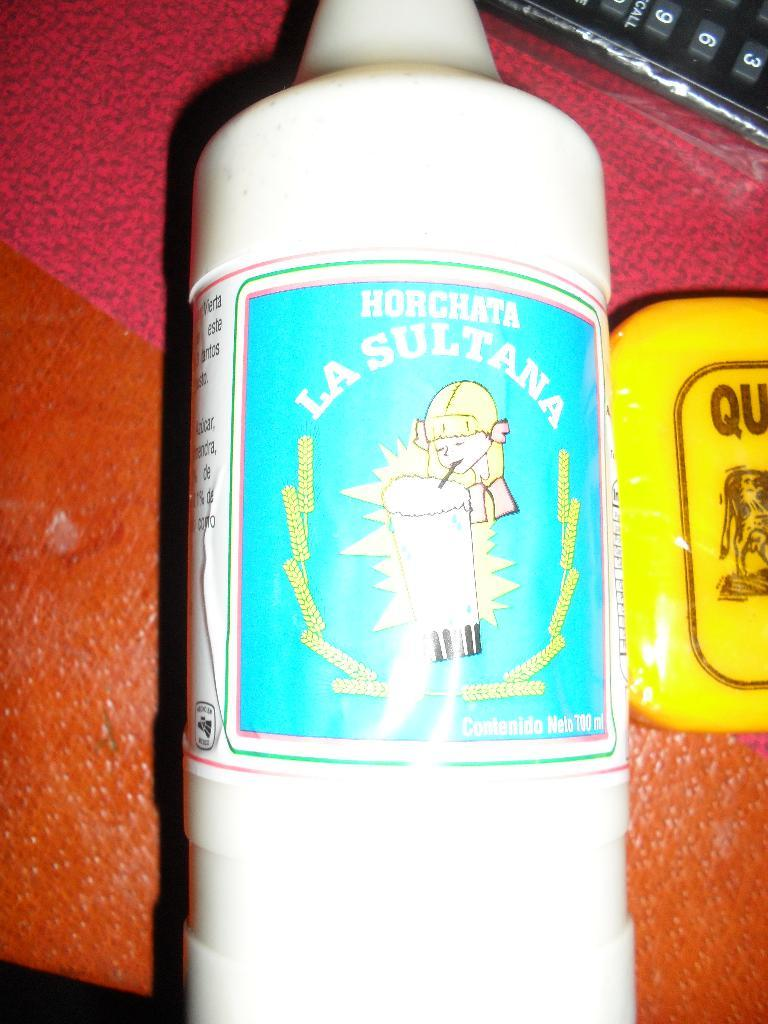What is the main object in the center of the image? There is a bottle in the center of the image. What can be seen on the right side of the image? There is a box on the right side of the image. Where is the keypad located in the image? A keypad is visible in the top right corner of the image. What is the color of one of the objects in the image? There is a red-colored object in the image. How many bikes are parked next to the red-colored object in the image? There are no bikes present in the image. 